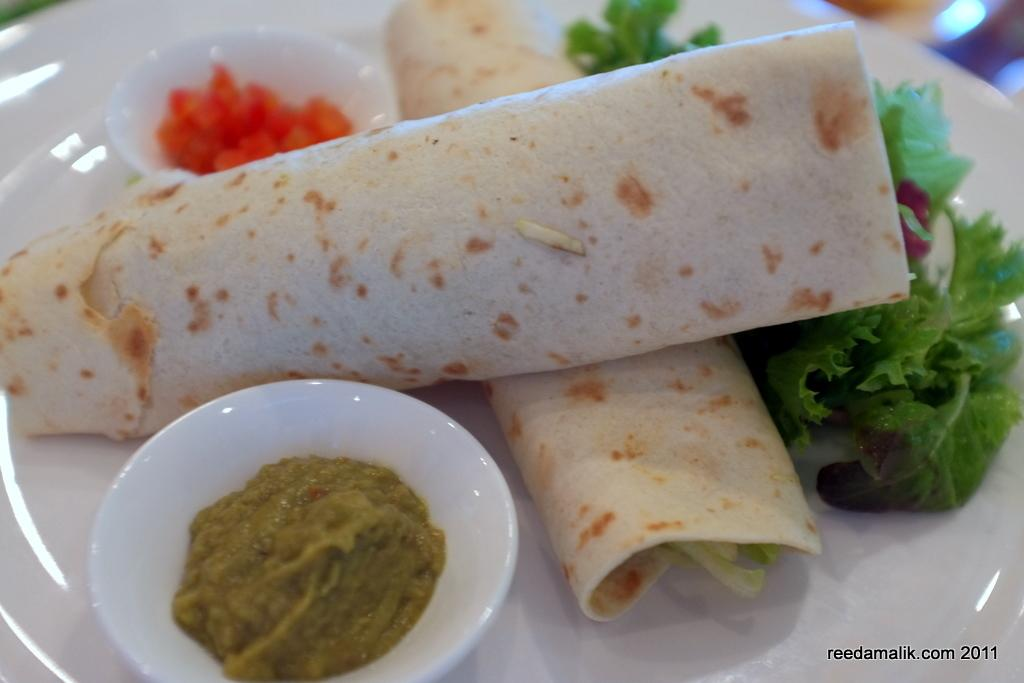What is on the plate that is visible in the image? The plate contains two wraps. What type of food is present in the image besides the wraps? There are leafy vegetables, a bowl with sauce, and a bowl with fruits in the image. How many bowls are there in the image? There are two bowls in the image, one with sauce and one with fruits. What type of bubble can be seen floating in the image? There are no bubbles present in the image. Is there a ball visible in the image? There is no ball present in the image. 